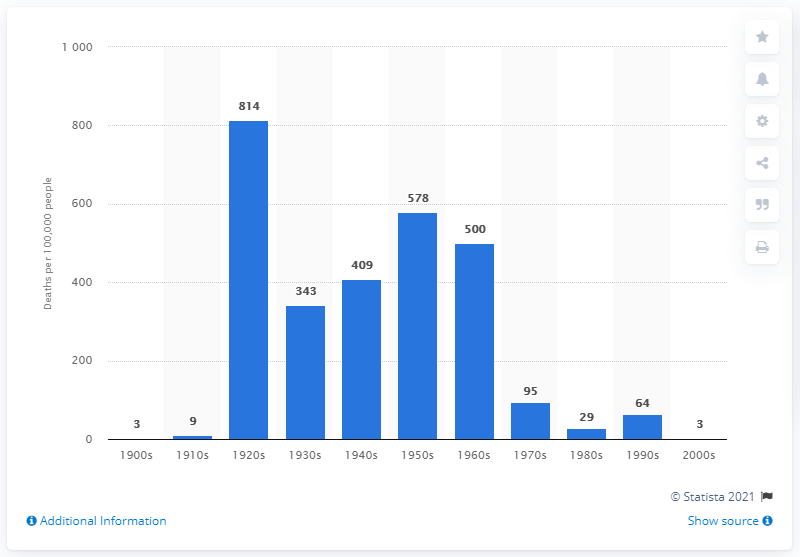Give some essential details in this illustration. In the 1920s, an estimated 814 people per 100,000 died as a result of famine. 